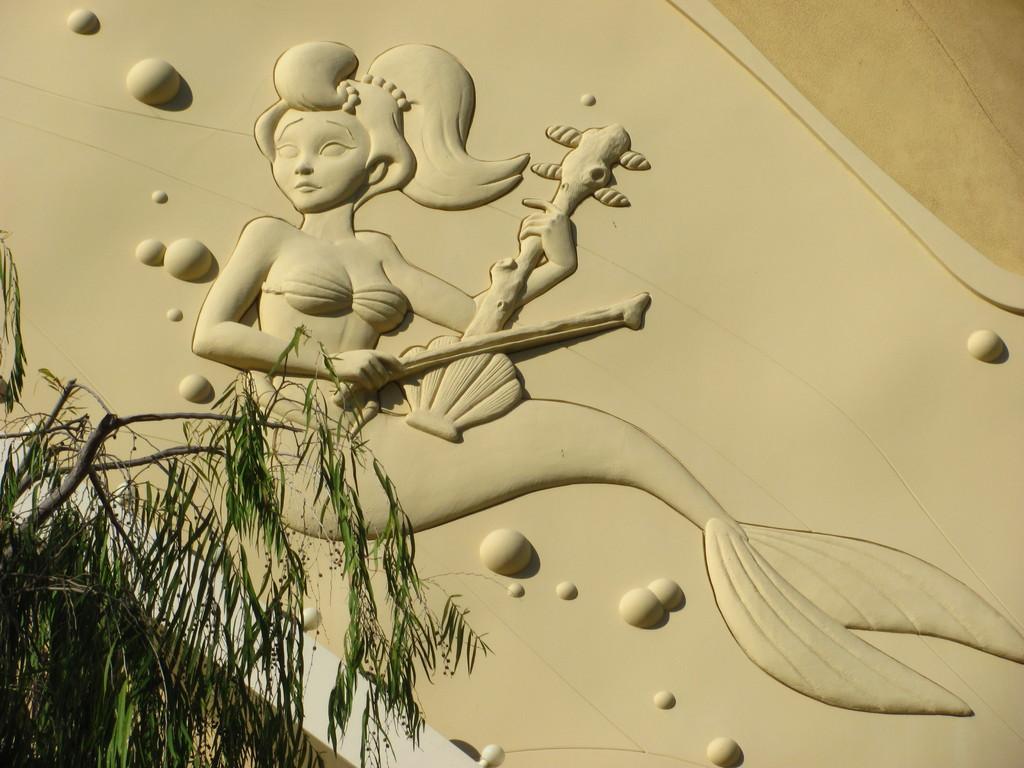In one or two sentences, can you explain what this image depicts? In the image we can see there is an art of mermaid playing musical instrument on the wall and there is a tree. 